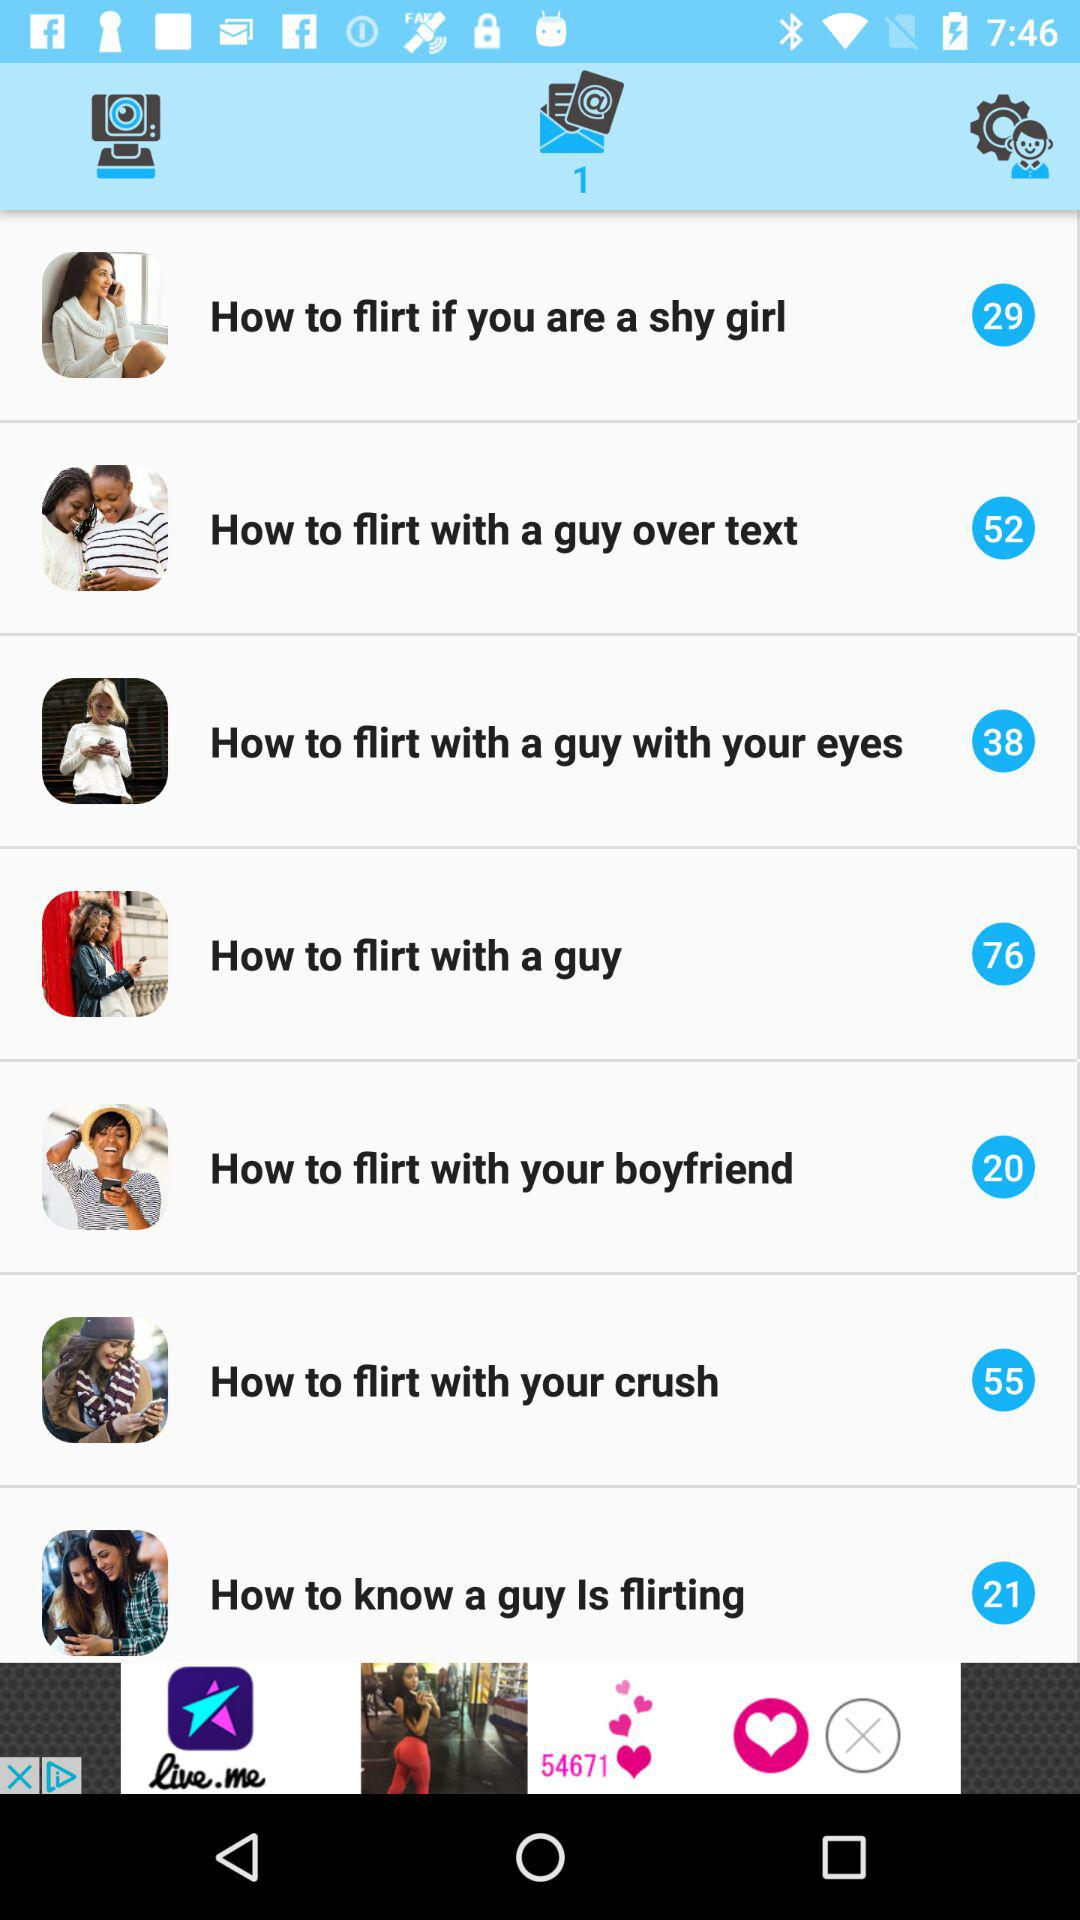What is the number of tips for the topic "How to flirt with a guy with your eyes"? The number of tips is 38. 